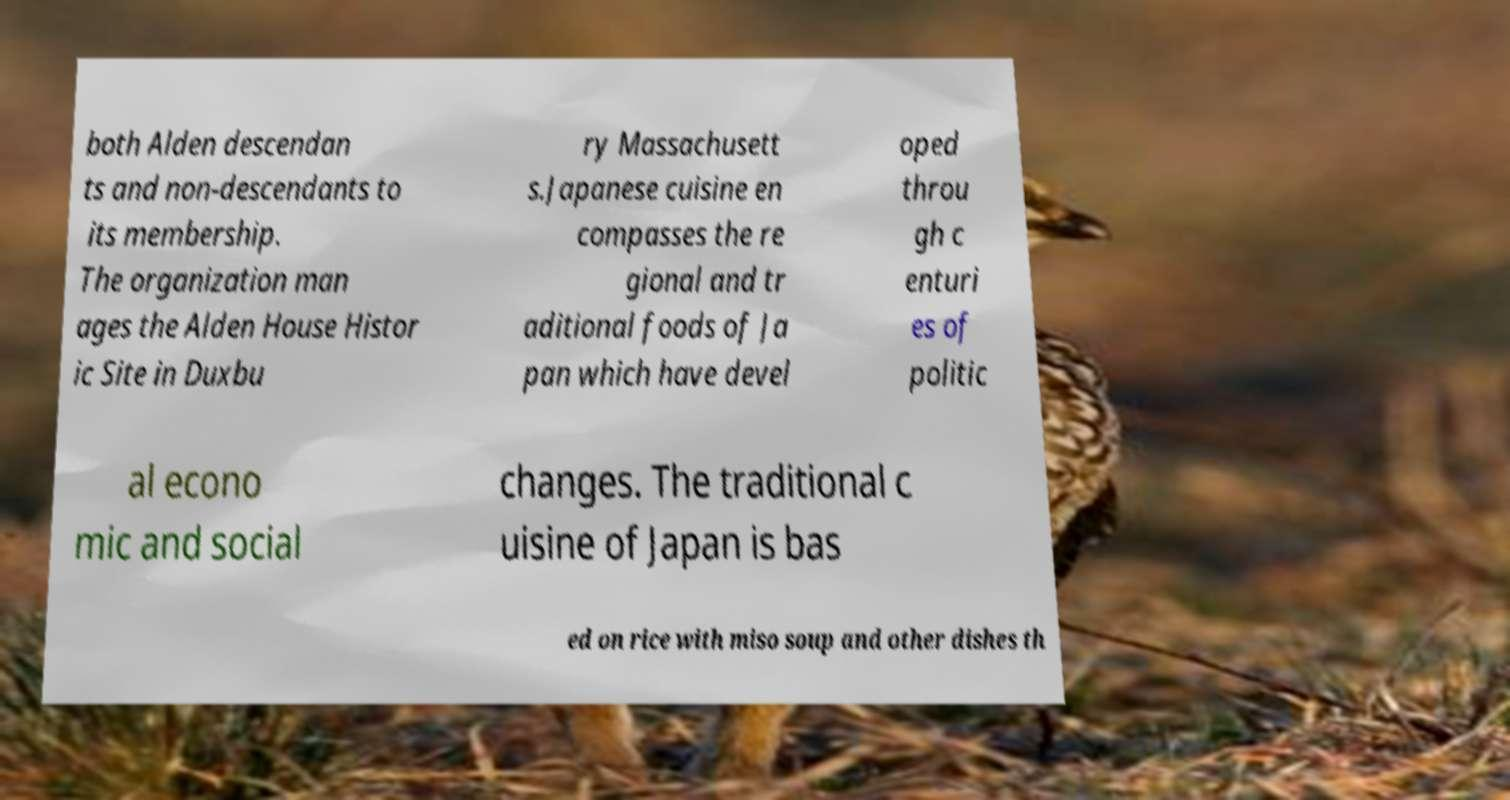Could you extract and type out the text from this image? both Alden descendan ts and non-descendants to its membership. The organization man ages the Alden House Histor ic Site in Duxbu ry Massachusett s.Japanese cuisine en compasses the re gional and tr aditional foods of Ja pan which have devel oped throu gh c enturi es of politic al econo mic and social changes. The traditional c uisine of Japan is bas ed on rice with miso soup and other dishes th 